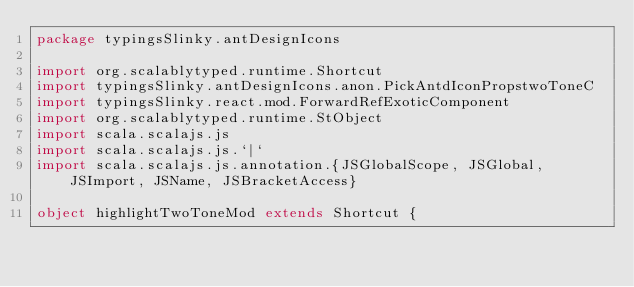Convert code to text. <code><loc_0><loc_0><loc_500><loc_500><_Scala_>package typingsSlinky.antDesignIcons

import org.scalablytyped.runtime.Shortcut
import typingsSlinky.antDesignIcons.anon.PickAntdIconPropstwoToneC
import typingsSlinky.react.mod.ForwardRefExoticComponent
import org.scalablytyped.runtime.StObject
import scala.scalajs.js
import scala.scalajs.js.`|`
import scala.scalajs.js.annotation.{JSGlobalScope, JSGlobal, JSImport, JSName, JSBracketAccess}

object highlightTwoToneMod extends Shortcut {
  </code> 